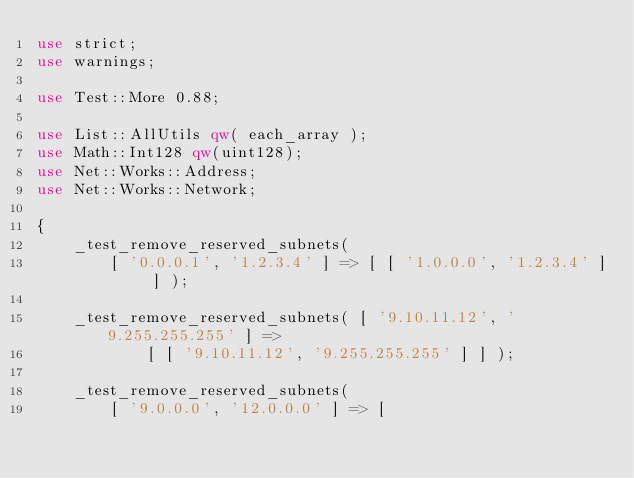<code> <loc_0><loc_0><loc_500><loc_500><_Perl_>use strict;
use warnings;

use Test::More 0.88;

use List::AllUtils qw( each_array );
use Math::Int128 qw(uint128);
use Net::Works::Address;
use Net::Works::Network;

{
    _test_remove_reserved_subnets(
        [ '0.0.0.1', '1.2.3.4' ] => [ [ '1.0.0.0', '1.2.3.4' ] ] );

    _test_remove_reserved_subnets( [ '9.10.11.12', '9.255.255.255' ] =>
            [ [ '9.10.11.12', '9.255.255.255' ] ] );

    _test_remove_reserved_subnets(
        [ '9.0.0.0', '12.0.0.0' ] => [</code> 